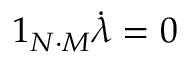Convert formula to latex. <formula><loc_0><loc_0><loc_500><loc_500>1 _ { N \cdot M } \dot { \lambda } = 0</formula> 